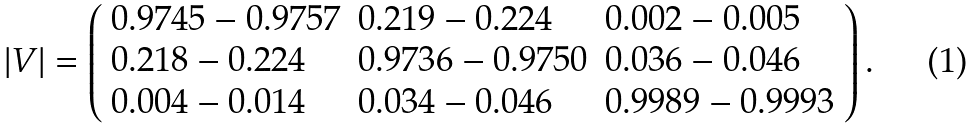Convert formula to latex. <formula><loc_0><loc_0><loc_500><loc_500>| V | = \left ( \begin{array} { l l l } 0 . 9 7 4 5 - 0 . 9 7 5 7 & 0 . 2 1 9 - 0 . 2 2 4 & 0 . 0 0 2 - 0 . 0 0 5 \\ 0 . 2 1 8 - 0 . 2 2 4 & 0 . 9 7 3 6 - 0 . 9 7 5 0 & 0 . 0 3 6 - 0 . 0 4 6 \\ 0 . 0 0 4 - 0 . 0 1 4 & 0 . 0 3 4 - 0 . 0 4 6 & 0 . 9 9 8 9 - 0 . 9 9 9 3 \end{array} \right ) .</formula> 